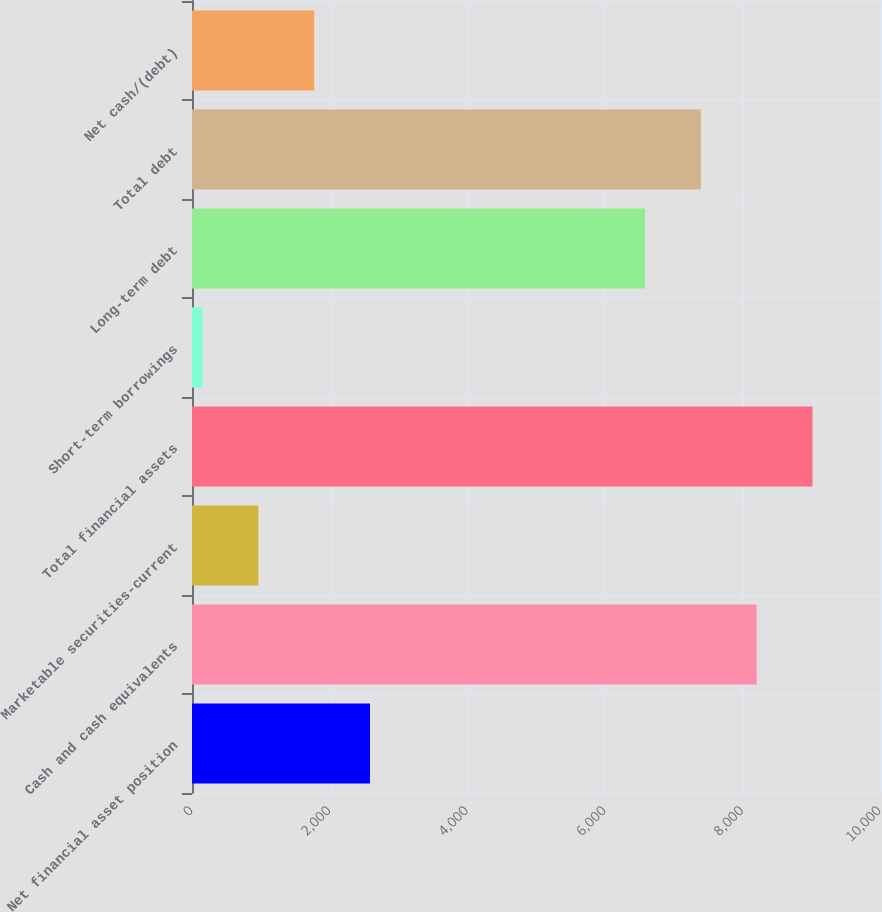Convert chart. <chart><loc_0><loc_0><loc_500><loc_500><bar_chart><fcel>Net financial asset position<fcel>Cash and cash equivalents<fcel>Marketable securities-current<fcel>Total financial assets<fcel>Short-term borrowings<fcel>Long-term debt<fcel>Total debt<fcel>Net cash/(debt)<nl><fcel>2587.3<fcel>8207.2<fcel>965.1<fcel>9018.3<fcel>154<fcel>6585<fcel>7396.1<fcel>1776.2<nl></chart> 